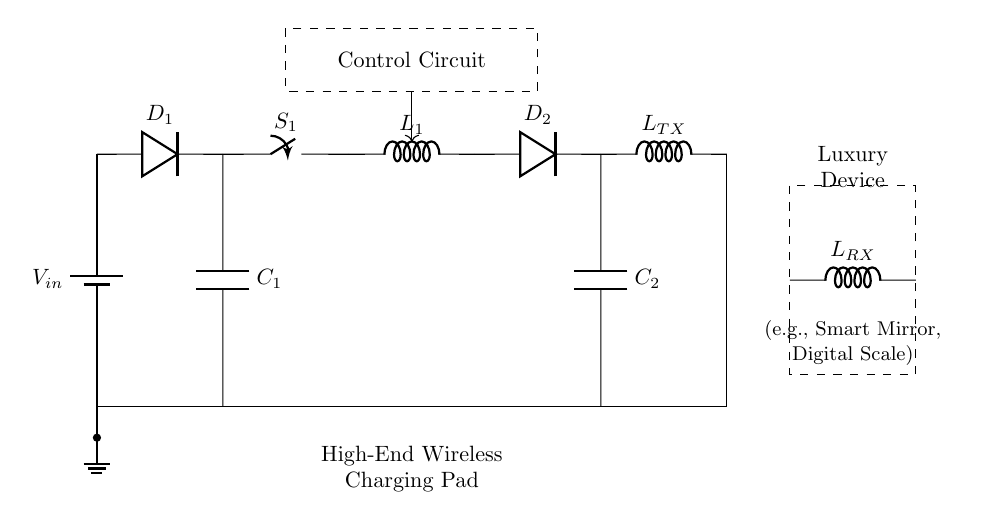What is the input voltage of this circuit? The input voltage, noted as V_in, is indicated at the top left corner of the circuit diagram. This is the voltage supplied by the battery.
Answer: V_in What type of circuit component is D1? D1 is labeled as a diode in the circuit diagram. A diode allows current to flow in one direction only, providing rectification from AC to DC.
Answer: Diode How many capacitors are in the circuit? There are two capacitors labeled as C1 and C2, each serving different functions in the circuit's filtering and stabilization processes.
Answer: 2 What is the purpose of the control circuit? The control circuit, depicted as a dashed box, manages the operation of the wireless charger, ensuring proper functionality and safety during charging.
Answer: Management What is the relationship between L_TX and L_RX? L_TX is the transmitting coil that generates the electromagnetic field for wireless charging, while L_RX is the receiving coil that captures this field to convert it back to electrical energy for the device.
Answer: Transmitting and receiving Which components are responsible for converting AC to DC? The components responsible for conversion are D1 (diode) and the capacitors C1 and C2, as they work together to rectify and filter the AC input into a usable DC output.
Answer: D1, C1, C2 What luxury devices could be powered by this charging pad? The circuit diagram includes a label suggesting that luxury devices such as smart mirrors and digital scales could be powered by the wireless charging pad, indicating versatility in its application.
Answer: Smart mirror, digital scale 